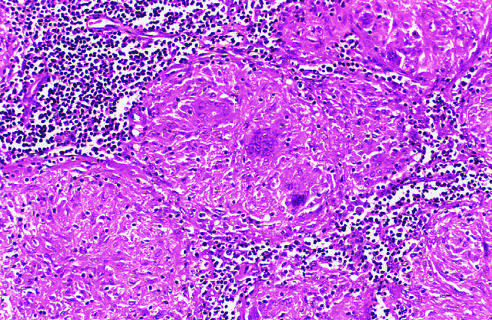does the left ventricular wall show several multinucleate giant cells?
Answer the question using a single word or phrase. No 